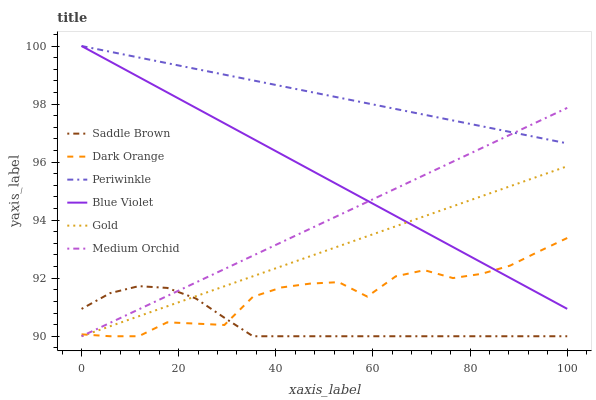Does Saddle Brown have the minimum area under the curve?
Answer yes or no. Yes. Does Periwinkle have the maximum area under the curve?
Answer yes or no. Yes. Does Gold have the minimum area under the curve?
Answer yes or no. No. Does Gold have the maximum area under the curve?
Answer yes or no. No. Is Medium Orchid the smoothest?
Answer yes or no. Yes. Is Dark Orange the roughest?
Answer yes or no. Yes. Is Gold the smoothest?
Answer yes or no. No. Is Gold the roughest?
Answer yes or no. No. Does Dark Orange have the lowest value?
Answer yes or no. Yes. Does Periwinkle have the lowest value?
Answer yes or no. No. Does Blue Violet have the highest value?
Answer yes or no. Yes. Does Gold have the highest value?
Answer yes or no. No. Is Dark Orange less than Periwinkle?
Answer yes or no. Yes. Is Blue Violet greater than Saddle Brown?
Answer yes or no. Yes. Does Dark Orange intersect Medium Orchid?
Answer yes or no. Yes. Is Dark Orange less than Medium Orchid?
Answer yes or no. No. Is Dark Orange greater than Medium Orchid?
Answer yes or no. No. Does Dark Orange intersect Periwinkle?
Answer yes or no. No. 